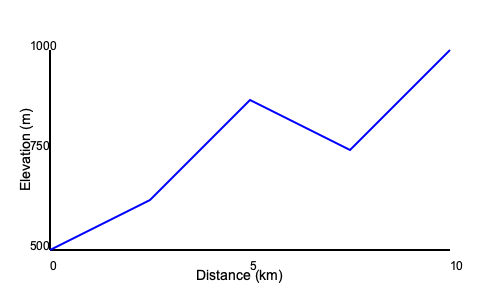Based on the elevation profile of this 10 km trail, estimate the total hiking time if you maintain an average speed of 3 km/h on flat terrain, adding 1 hour for every 300 meters of elevation gain and subtracting 30 minutes for every 300 meters of elevation loss. To estimate the hiking time, we need to follow these steps:

1. Calculate the base hiking time:
   Base time = Distance / Speed
   $\text{Base time} = 10 \text{ km} / 3 \text{ km/h} = 3.33 \text{ hours}$

2. Determine the total elevation gain and loss:
   Starting elevation: 500 m
   Highest point: 1000 m
   Ending elevation: 750 m
   Total elevation gain: $1000 \text{ m} - 500 \text{ m} = 500 \text{ m}$
   Total elevation loss: $1000 \text{ m} - 750 \text{ m} = 250 \text{ m}$

3. Calculate additional time for elevation gain:
   $\text{Time for elevation gain} = 500 \text{ m} / 300 \text{ m} \times 1 \text{ hour} = 1.67 \text{ hours}$

4. Calculate time saved from elevation loss:
   $\text{Time saved from elevation loss} = 250 \text{ m} / 300 \text{ m} \times 0.5 \text{ hours} = 0.42 \text{ hours}$

5. Sum up the total hiking time:
   $\text{Total time} = \text{Base time} + \text{Time for elevation gain} - \text{Time saved from elevation loss}$
   $\text{Total time} = 3.33 + 1.67 - 0.42 = 4.58 \text{ hours}$

6. Round to the nearest quarter hour:
   4.58 hours ≈ 4 hours and 35 minutes
Answer: 4 hours and 35 minutes 